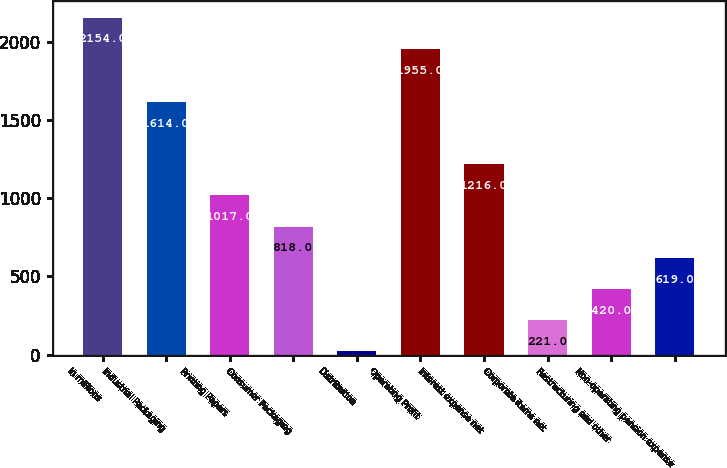Convert chart to OTSL. <chart><loc_0><loc_0><loc_500><loc_500><bar_chart><fcel>In millions<fcel>Industrial Packaging<fcel>Printing Papers<fcel>Consumer Packaging<fcel>Distribution<fcel>Operating Profit<fcel>Interest expense net<fcel>Corporate items net<fcel>Restructuring and other<fcel>Non-operating pension expense<nl><fcel>2154<fcel>1614<fcel>1017<fcel>818<fcel>22<fcel>1955<fcel>1216<fcel>221<fcel>420<fcel>619<nl></chart> 